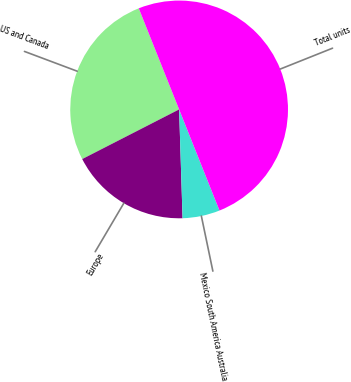<chart> <loc_0><loc_0><loc_500><loc_500><pie_chart><fcel>US and Canada<fcel>Europe<fcel>Mexico South America Australia<fcel>Total units<nl><fcel>26.49%<fcel>17.97%<fcel>5.54%<fcel>50.0%<nl></chart> 